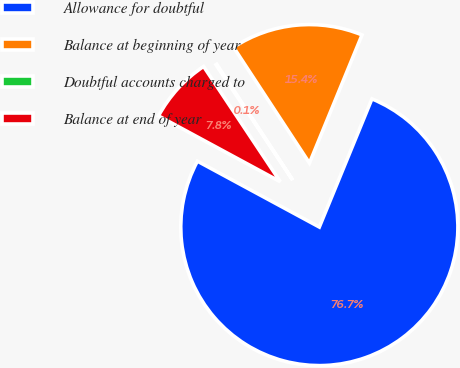<chart> <loc_0><loc_0><loc_500><loc_500><pie_chart><fcel>Allowance for doubtful<fcel>Balance at beginning of year<fcel>Doubtful accounts charged to<fcel>Balance at end of year<nl><fcel>76.69%<fcel>15.43%<fcel>0.11%<fcel>7.77%<nl></chart> 